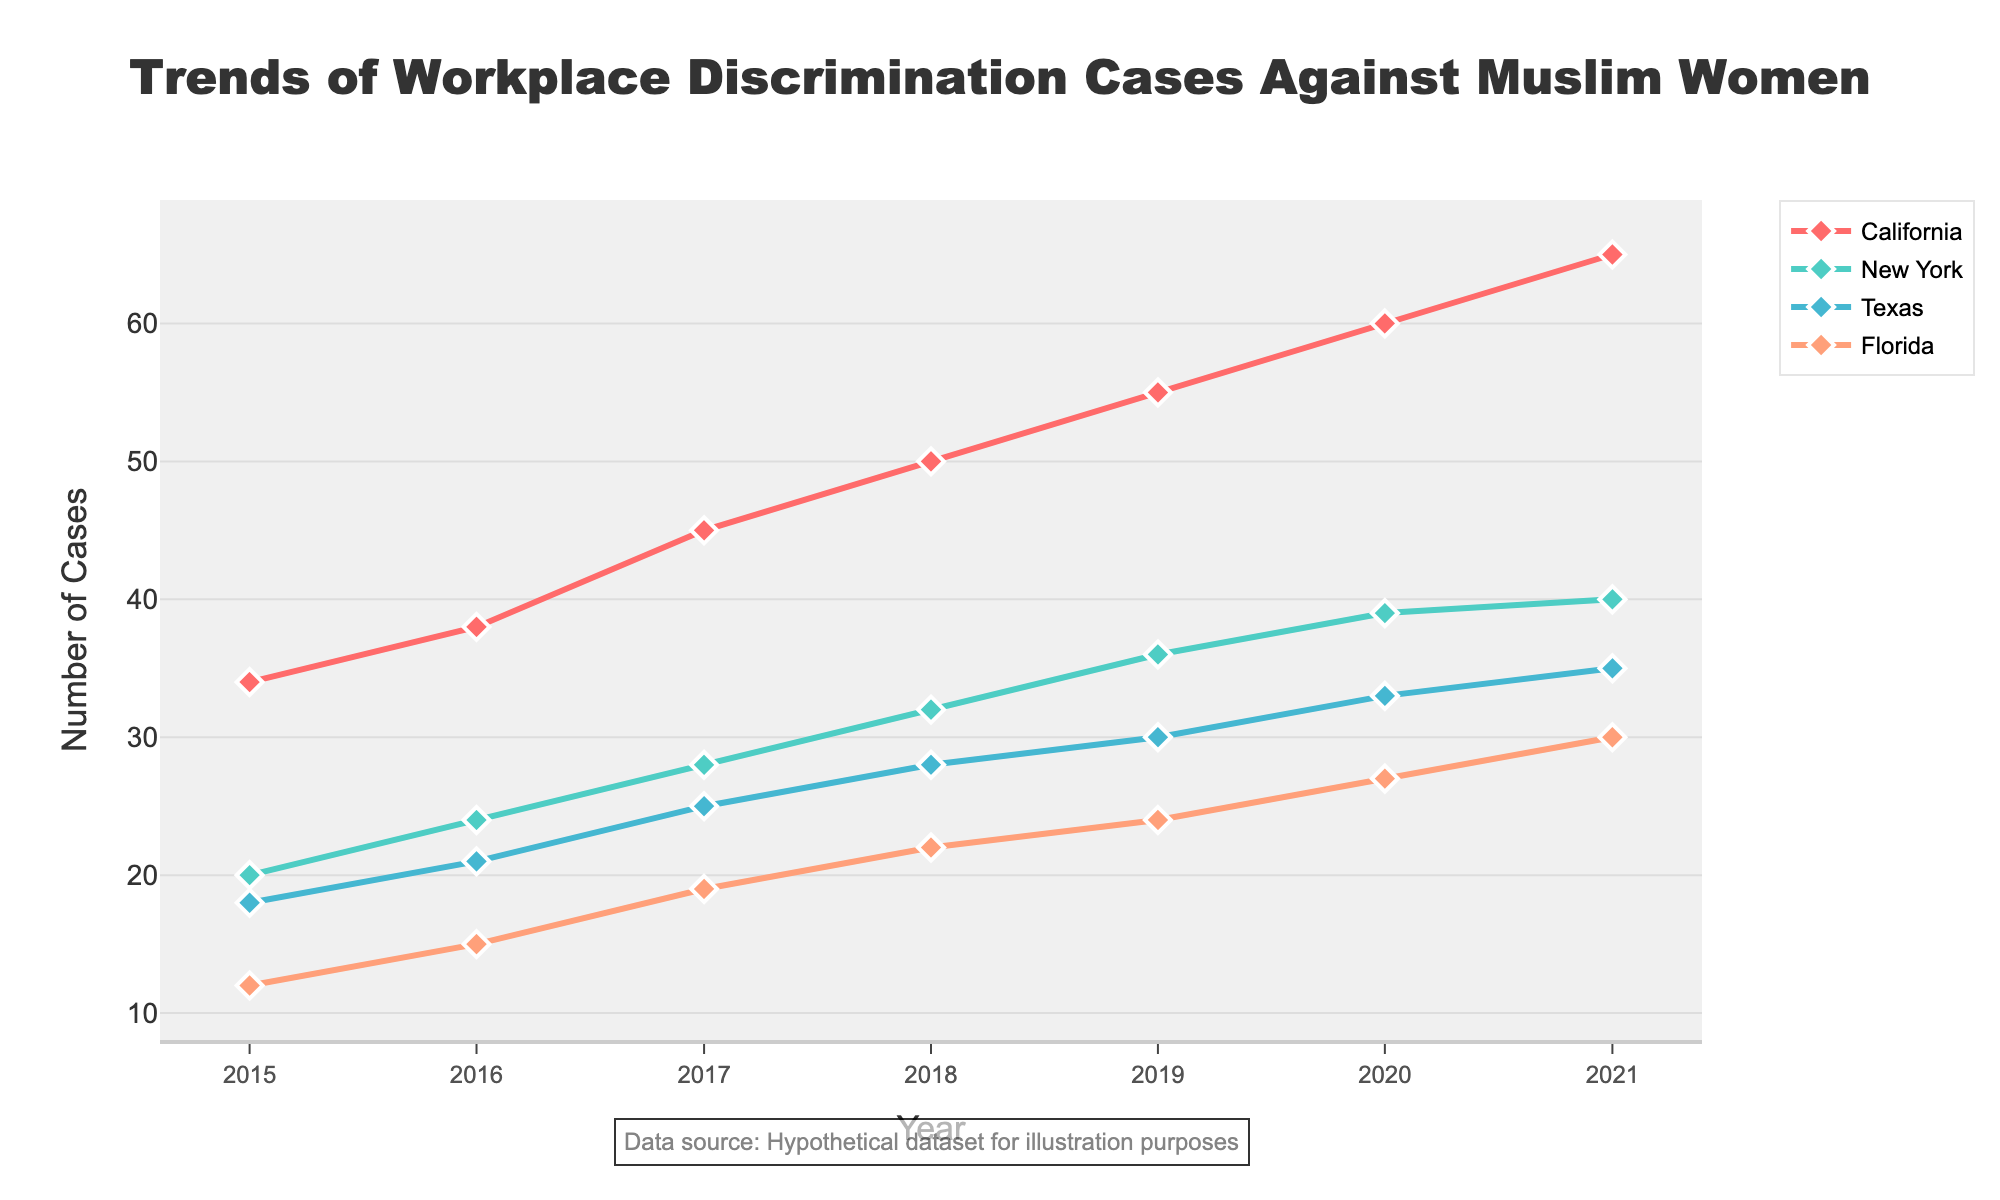What is the title of the chart? The title is located at the top center of the chart and usually summarizes the main topic of the plot.
Answer: Trends of Workplace Discrimination Cases Against Muslim Women What is the number of workplace discrimination cases filed in California in 2020? Locate the line corresponding to California (pink color), find the data point for the year 2020 on the x-axis, and read the y-axis value next to it.
Answer: 60 Which state had the most significant increase in the number of workplace discrimination cases from 2015 to 2021? To determine this, calculate the difference in the number of cases between 2021 and 2015 for each state. Compare these differences to find the state with the highest increase.
Answer: California How many total cases were filed in New York across all years from 2015 to 2021? Add the number of cases in New York for each year: 20 + 24 + 28 + 32 + 36 + 39 + 40.
Answer: 219 In which year did Texas see the highest number of workplace discrimination cases filed? Locate the line corresponding to Texas (blue color), identify the highest point on this line, and note the year associated with this point on the x-axis.
Answer: 2021 How does the trend in Florida compare to that in California from 2015 to 2021? Compare the overall shapes of the lines for Florida (orange color) and California (pink color). Look at whether each line generally slopes upwards or downwards and if one line is steeper.
Answer: Both show an increasing trend, but California's increase is steeper What was the number of cases in all states combined in 2017? Sum the number of cases in each state for the year 2017: 45 (California) + 28 (New York) + 25 (Texas) + 19 (Florida).
Answer: 117 Which state consistently had the lowest number of cases over the entire period? Compare the lines for each state to see which one stays closest to the bottom for all years.
Answer: Florida Calculate the average number of cases filed per year in Texas from 2015 to 2021. Add the number of cases in Texas for each year and divide by the number of years: (18 + 21 + 25 + 28 + 30 + 33 + 35) / 7.
Answer: 27.14 Is there any state where the number of cases remained stable without much change? Look for a line that shows minimal fluctuation and remains relatively flat over the years.
Answer: No, all states show an increasing trend 